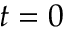Convert formula to latex. <formula><loc_0><loc_0><loc_500><loc_500>t = 0</formula> 